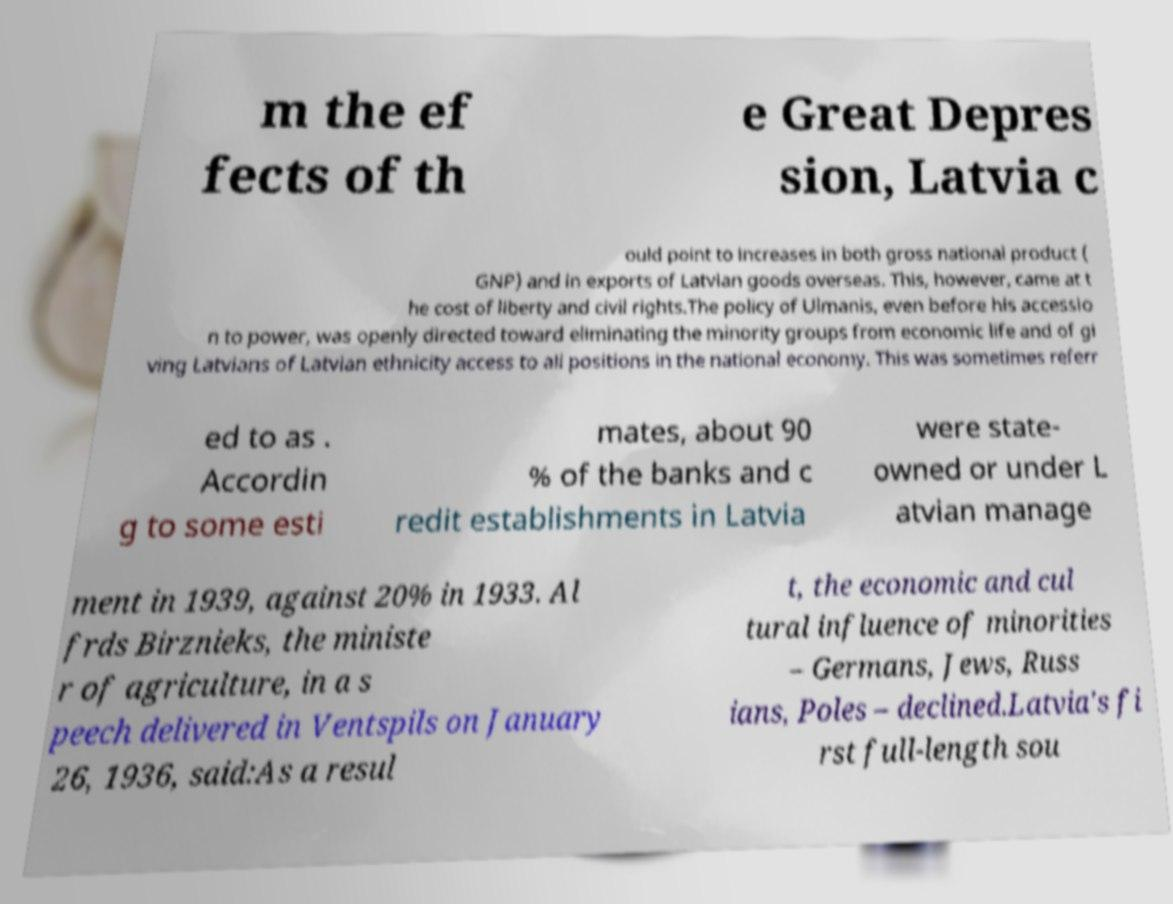Could you assist in decoding the text presented in this image and type it out clearly? m the ef fects of th e Great Depres sion, Latvia c ould point to increases in both gross national product ( GNP) and in exports of Latvian goods overseas. This, however, came at t he cost of liberty and civil rights.The policy of Ulmanis, even before his accessio n to power, was openly directed toward eliminating the minority groups from economic life and of gi ving Latvians of Latvian ethnicity access to all positions in the national economy. This was sometimes referr ed to as . Accordin g to some esti mates, about 90 % of the banks and c redit establishments in Latvia were state- owned or under L atvian manage ment in 1939, against 20% in 1933. Al frds Birznieks, the ministe r of agriculture, in a s peech delivered in Ventspils on January 26, 1936, said:As a resul t, the economic and cul tural influence of minorities – Germans, Jews, Russ ians, Poles – declined.Latvia's fi rst full-length sou 